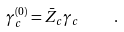<formula> <loc_0><loc_0><loc_500><loc_500>\gamma _ { c } ^ { ( 0 ) } = \bar { Z } _ { c } \gamma _ { c } \quad .</formula> 